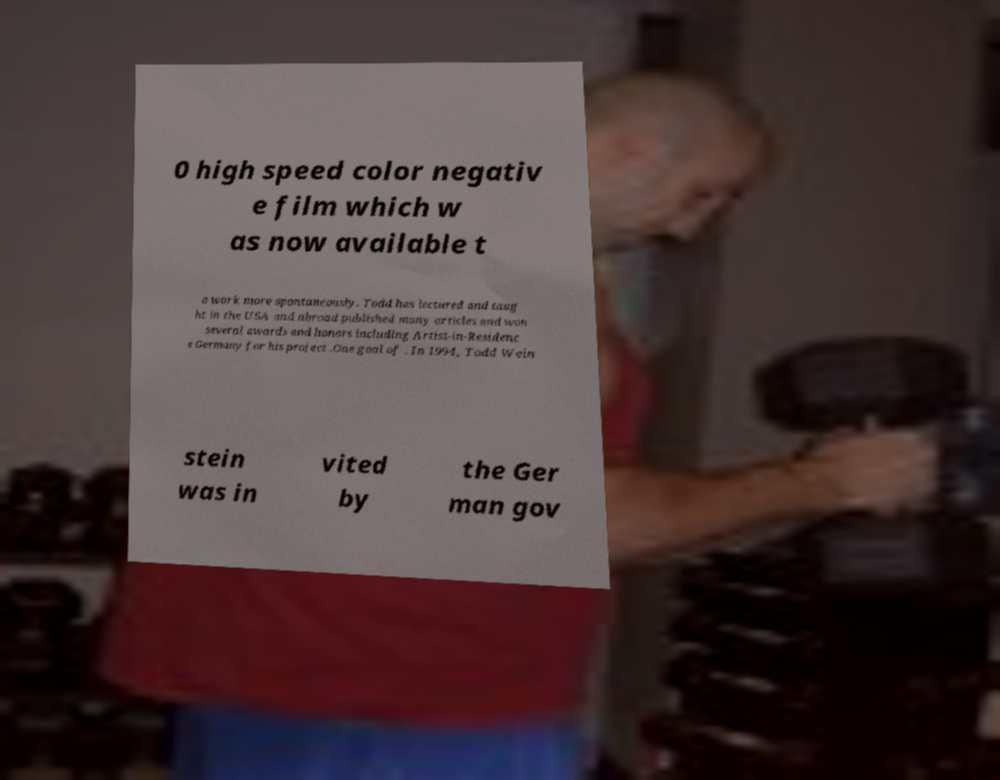Can you read and provide the text displayed in the image?This photo seems to have some interesting text. Can you extract and type it out for me? 0 high speed color negativ e film which w as now available t o work more spontaneously. Todd has lectured and taug ht in the USA and abroad published many articles and won several awards and honors including Artist-in-Residenc e Germany for his project .One goal of . In 1994, Todd Wein stein was in vited by the Ger man gov 